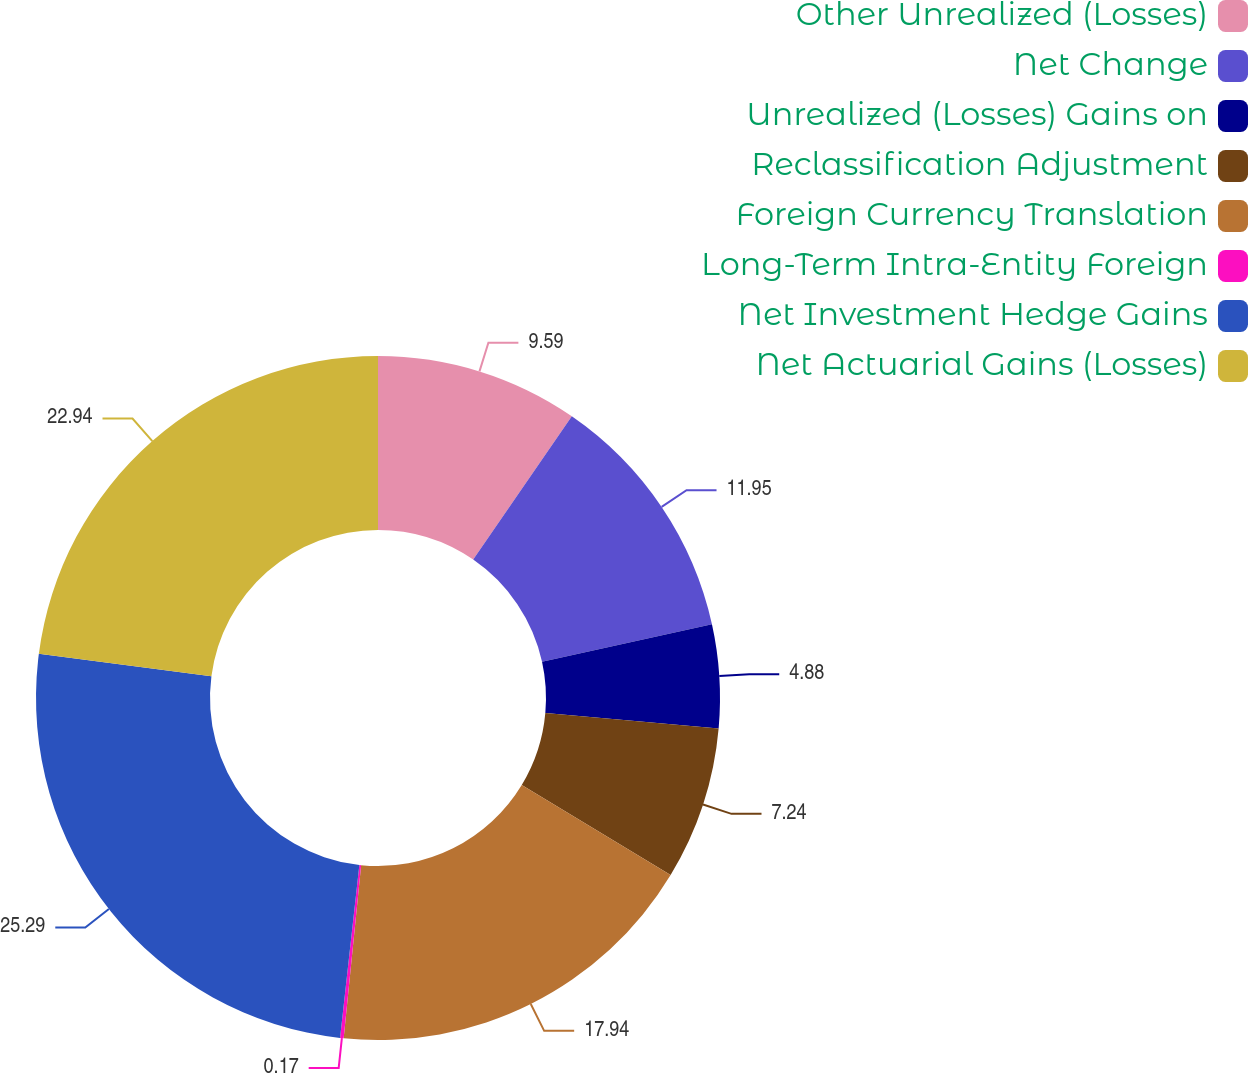Convert chart. <chart><loc_0><loc_0><loc_500><loc_500><pie_chart><fcel>Other Unrealized (Losses)<fcel>Net Change<fcel>Unrealized (Losses) Gains on<fcel>Reclassification Adjustment<fcel>Foreign Currency Translation<fcel>Long-Term Intra-Entity Foreign<fcel>Net Investment Hedge Gains<fcel>Net Actuarial Gains (Losses)<nl><fcel>9.59%<fcel>11.95%<fcel>4.88%<fcel>7.24%<fcel>17.94%<fcel>0.17%<fcel>25.29%<fcel>22.94%<nl></chart> 